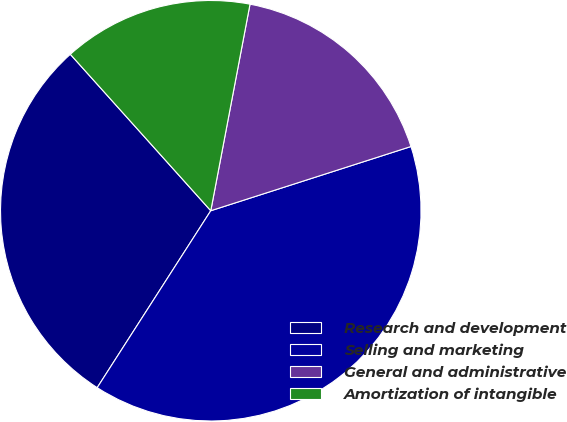Convert chart. <chart><loc_0><loc_0><loc_500><loc_500><pie_chart><fcel>Research and development<fcel>Selling and marketing<fcel>General and administrative<fcel>Amortization of intangible<nl><fcel>29.27%<fcel>39.02%<fcel>17.07%<fcel>14.63%<nl></chart> 